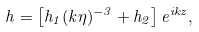Convert formula to latex. <formula><loc_0><loc_0><loc_500><loc_500>h = \left [ h _ { 1 } ( k \eta ) ^ { - 3 } + h _ { 2 } \right ] e ^ { i k z } ,</formula> 